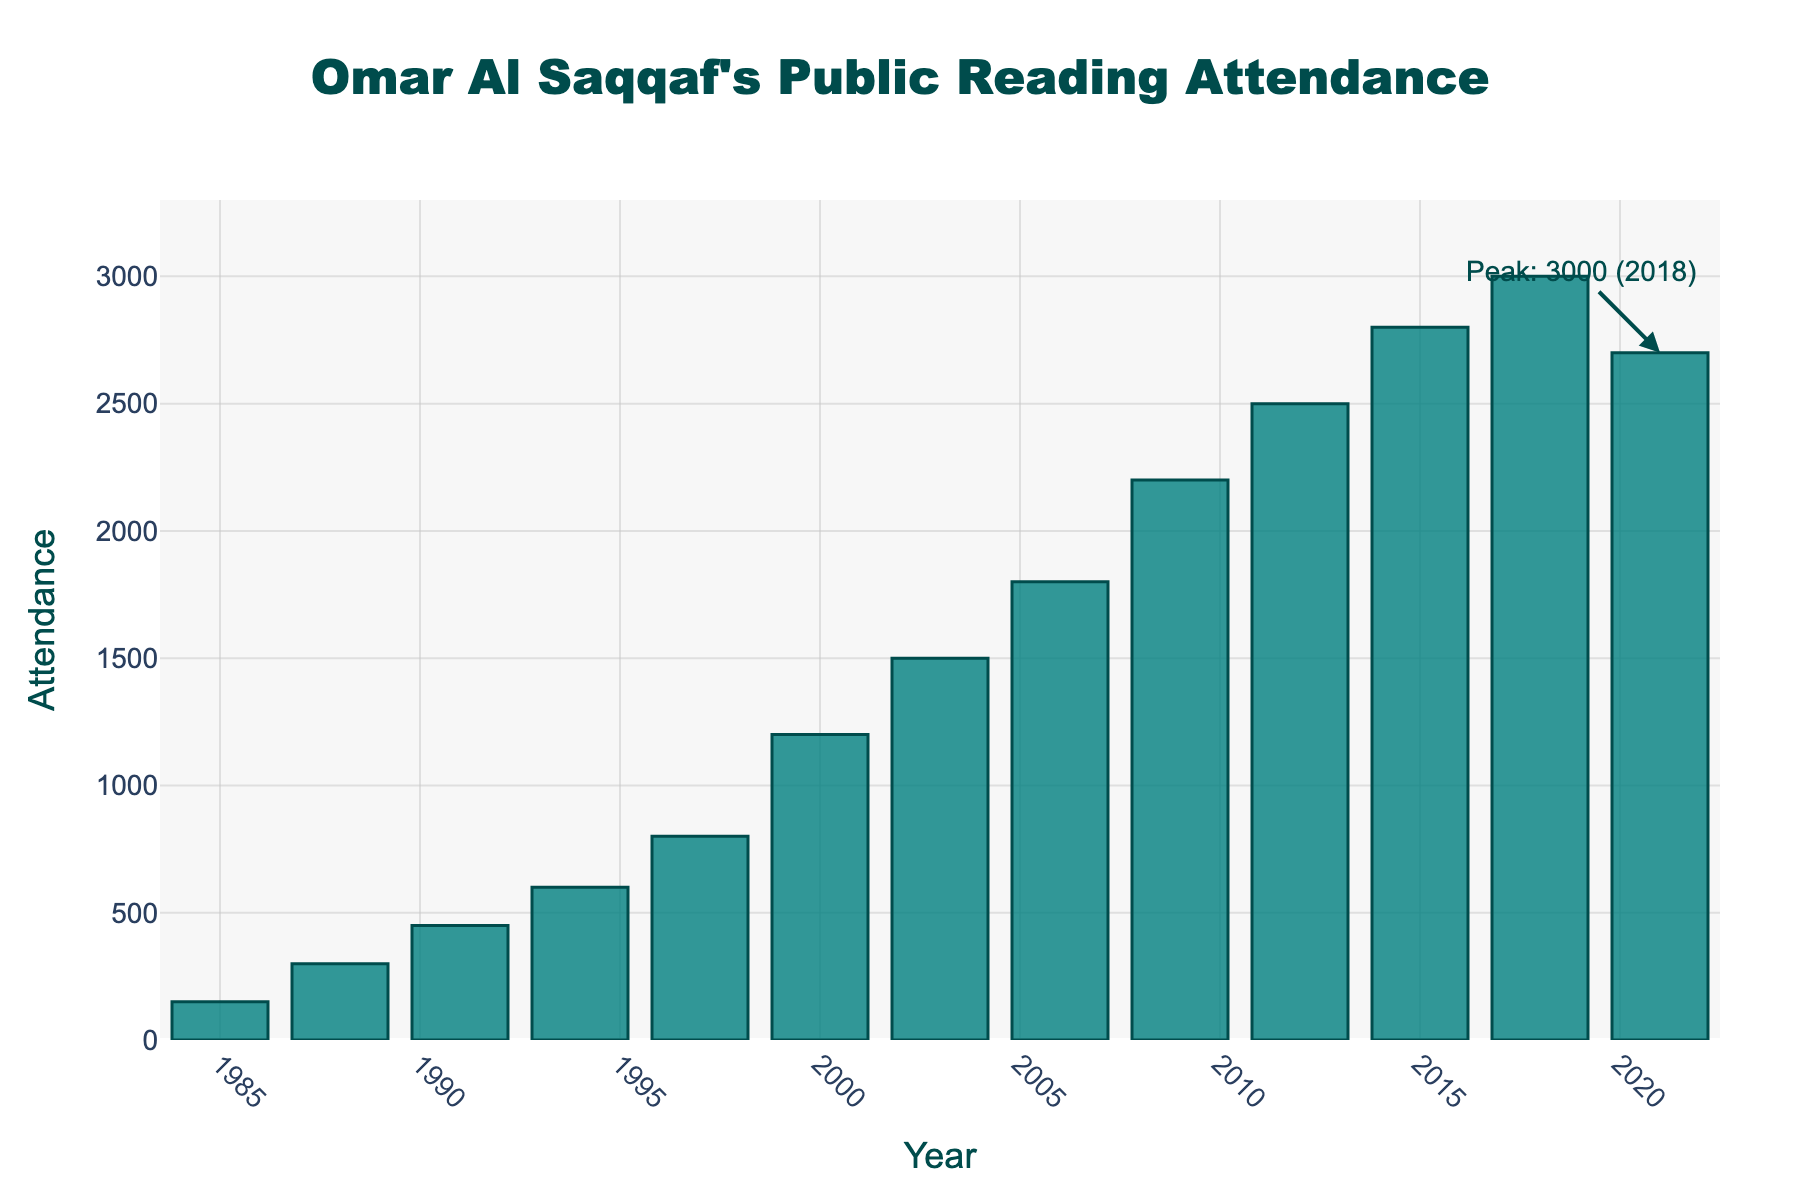What is the attendance figure in 2000? To find the attendance figure for the year 2000, locate the bar labeled "2000" on the x-axis and read the height value from the y-axis, which corresponds to 1200.
Answer: 1200 In which year did Omar Al Saqqaf's public reading attendance peak? Identify the year with the tallest bar in the chart. The annotation indicates that the peak attendance was 3000 in 2018.
Answer: 2018 How many years did it take for the attendance to increase from 800 to 1500? Find the years where the attendance was 800 (1997) and 1500 (2003). Calculate the difference: 2003 - 1997 = 6 years.
Answer: 6 years What is the overall trend in the attendance figures from 1985 to 2021? Observe the general direction of the bars from left (1985) to right (2021). The bars generally increase in height, indicating an upward trend until 2018, after which there is a slight decrease.
Answer: Upward trend with a slight decrease towards the end Compare the attendance in 2006 and 2021. Which year had higher attendance? Compare the heights of the bars for 2006 and 2021. The height for 2021 is greater (2700) than that of 2006 (1800).
Answer: 2021 What is the difference in attendance between 1994 and 1997? Subtract the attendance in 1994 (600) from that in 1997 (800): 800 - 600 = 200.
Answer: 200 On average, how much did the attendance increase every three years between 1985 and 2003? Calculate the difference in attendance between 1985 (150) and 2003 (1500). Then divide by the number of 3-year intervals: (1500 - 150) / ((2003 - 1985) / 3) = 1350 / 6 = 225.
Answer: 225 What is the color of the bars representing the attendance figures? The bars are teal in color with darker edges. This is based on the visual observation of the chart's bar color.
Answer: Teal with darker edges Between which pair of consecutive years is the largest increase in attendance observed? Calculate the difference in attendance for each pair of consecutive years and identify the largest increase. The largest increase occurs between 2000 (1200) and 2003 (1500), with a difference of 300.
Answer: 2000 to 2003 What is the visual feature used to highlight the year with peak attendance? An annotation with an arrow pointing to the tallest bar, indicating the peak value of 3000 in 2018, highlights the peak attendance visually.
Answer: Annotation with arrow 